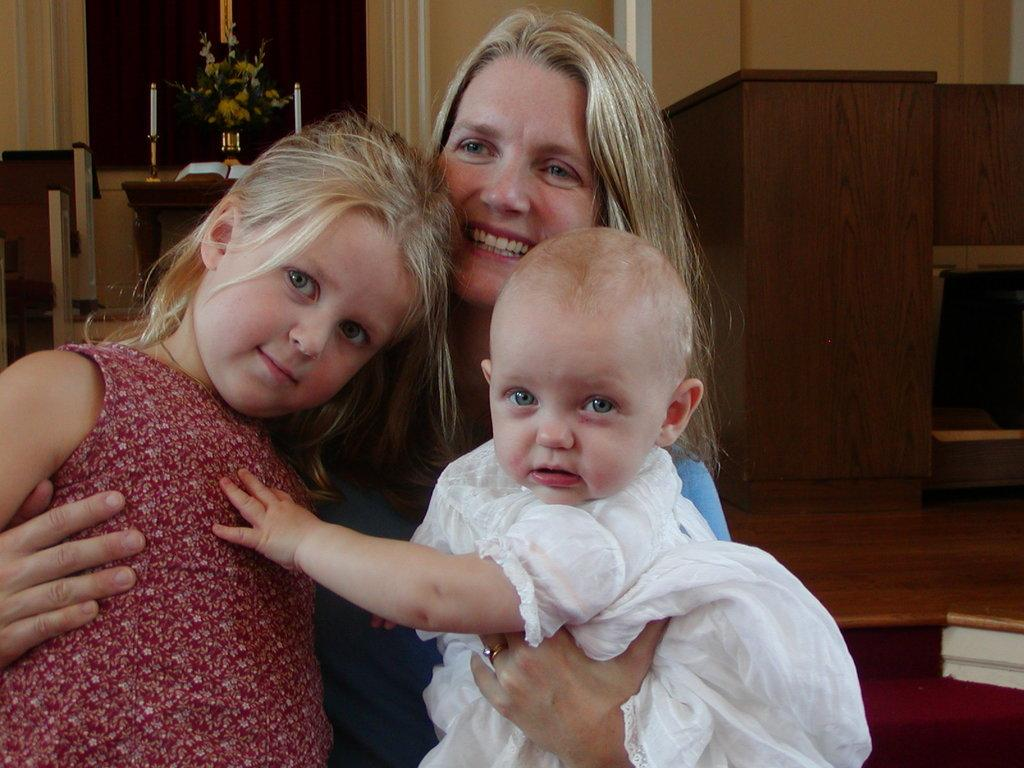Who is the main subject in the foreground of the picture? There is a woman in the foreground of the picture, along with two kids. How many children are present in the foreground of the picture? There are two kids in the foreground of the picture. What can be seen in the background of the picture? There is a table, a wall, a flower vase, candles, a book, and a curtain in the background of the picture. What type of prison is depicted in the background of the picture? There is no prison present in the image; it features a woman and two kids in the foreground, along with various objects in the background. What invention is being used by the woman in the picture? There is no specific invention being used by the woman in the picture; she is simply present with the two kids in the foreground. 